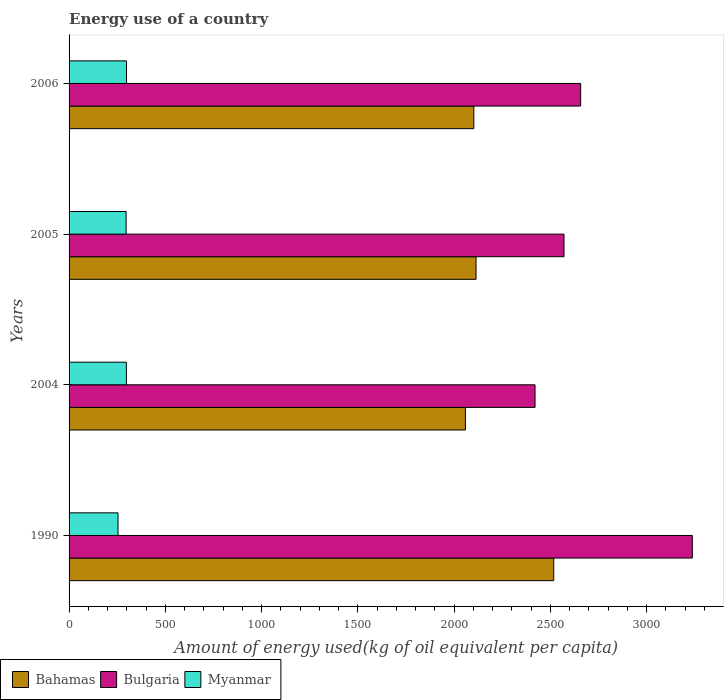How many different coloured bars are there?
Provide a succinct answer. 3. How many groups of bars are there?
Provide a short and direct response. 4. Are the number of bars on each tick of the Y-axis equal?
Your response must be concise. Yes. How many bars are there on the 4th tick from the top?
Offer a very short reply. 3. What is the label of the 4th group of bars from the top?
Offer a very short reply. 1990. What is the amount of energy used in in Myanmar in 2004?
Provide a succinct answer. 297.64. Across all years, what is the maximum amount of energy used in in Myanmar?
Your response must be concise. 298.12. Across all years, what is the minimum amount of energy used in in Bulgaria?
Offer a very short reply. 2420.35. In which year was the amount of energy used in in Bulgaria maximum?
Offer a very short reply. 1990. What is the total amount of energy used in in Bahamas in the graph?
Give a very brief answer. 8792.49. What is the difference between the amount of energy used in in Bulgaria in 1990 and that in 2006?
Provide a short and direct response. 580.03. What is the difference between the amount of energy used in in Myanmar in 2006 and the amount of energy used in in Bahamas in 2005?
Offer a terse response. -1815.82. What is the average amount of energy used in in Bulgaria per year?
Give a very brief answer. 2721.47. In the year 2004, what is the difference between the amount of energy used in in Myanmar and amount of energy used in in Bahamas?
Keep it short and to the point. -1761.02. What is the ratio of the amount of energy used in in Bahamas in 2005 to that in 2006?
Your answer should be compact. 1.01. Is the difference between the amount of energy used in in Myanmar in 2004 and 2005 greater than the difference between the amount of energy used in in Bahamas in 2004 and 2005?
Your answer should be very brief. Yes. What is the difference between the highest and the second highest amount of energy used in in Myanmar?
Your answer should be compact. 0.47. What is the difference between the highest and the lowest amount of energy used in in Myanmar?
Give a very brief answer. 43.89. What does the 3rd bar from the bottom in 2005 represents?
Your answer should be compact. Myanmar. Are all the bars in the graph horizontal?
Your answer should be very brief. Yes. How many years are there in the graph?
Offer a very short reply. 4. What is the difference between two consecutive major ticks on the X-axis?
Keep it short and to the point. 500. Does the graph contain grids?
Offer a very short reply. No. Where does the legend appear in the graph?
Give a very brief answer. Bottom left. What is the title of the graph?
Your response must be concise. Energy use of a country. What is the label or title of the X-axis?
Provide a short and direct response. Amount of energy used(kg of oil equivalent per capita). What is the label or title of the Y-axis?
Offer a terse response. Years. What is the Amount of energy used(kg of oil equivalent per capita) in Bahamas in 1990?
Provide a short and direct response. 2517.45. What is the Amount of energy used(kg of oil equivalent per capita) of Bulgaria in 1990?
Provide a short and direct response. 3237.35. What is the Amount of energy used(kg of oil equivalent per capita) of Myanmar in 1990?
Make the answer very short. 254.23. What is the Amount of energy used(kg of oil equivalent per capita) of Bahamas in 2004?
Your response must be concise. 2058.67. What is the Amount of energy used(kg of oil equivalent per capita) of Bulgaria in 2004?
Your answer should be very brief. 2420.35. What is the Amount of energy used(kg of oil equivalent per capita) of Myanmar in 2004?
Keep it short and to the point. 297.64. What is the Amount of energy used(kg of oil equivalent per capita) of Bahamas in 2005?
Your answer should be very brief. 2113.94. What is the Amount of energy used(kg of oil equivalent per capita) of Bulgaria in 2005?
Your answer should be very brief. 2570.86. What is the Amount of energy used(kg of oil equivalent per capita) of Myanmar in 2005?
Your answer should be very brief. 296.38. What is the Amount of energy used(kg of oil equivalent per capita) in Bahamas in 2006?
Make the answer very short. 2102.44. What is the Amount of energy used(kg of oil equivalent per capita) in Bulgaria in 2006?
Provide a succinct answer. 2657.33. What is the Amount of energy used(kg of oil equivalent per capita) of Myanmar in 2006?
Your response must be concise. 298.12. Across all years, what is the maximum Amount of energy used(kg of oil equivalent per capita) of Bahamas?
Your answer should be very brief. 2517.45. Across all years, what is the maximum Amount of energy used(kg of oil equivalent per capita) of Bulgaria?
Provide a succinct answer. 3237.35. Across all years, what is the maximum Amount of energy used(kg of oil equivalent per capita) in Myanmar?
Offer a very short reply. 298.12. Across all years, what is the minimum Amount of energy used(kg of oil equivalent per capita) in Bahamas?
Keep it short and to the point. 2058.67. Across all years, what is the minimum Amount of energy used(kg of oil equivalent per capita) in Bulgaria?
Offer a very short reply. 2420.35. Across all years, what is the minimum Amount of energy used(kg of oil equivalent per capita) in Myanmar?
Offer a terse response. 254.23. What is the total Amount of energy used(kg of oil equivalent per capita) in Bahamas in the graph?
Keep it short and to the point. 8792.49. What is the total Amount of energy used(kg of oil equivalent per capita) of Bulgaria in the graph?
Offer a very short reply. 1.09e+04. What is the total Amount of energy used(kg of oil equivalent per capita) in Myanmar in the graph?
Keep it short and to the point. 1146.36. What is the difference between the Amount of energy used(kg of oil equivalent per capita) in Bahamas in 1990 and that in 2004?
Provide a succinct answer. 458.78. What is the difference between the Amount of energy used(kg of oil equivalent per capita) of Bulgaria in 1990 and that in 2004?
Provide a succinct answer. 817. What is the difference between the Amount of energy used(kg of oil equivalent per capita) in Myanmar in 1990 and that in 2004?
Make the answer very short. -43.42. What is the difference between the Amount of energy used(kg of oil equivalent per capita) in Bahamas in 1990 and that in 2005?
Make the answer very short. 403.51. What is the difference between the Amount of energy used(kg of oil equivalent per capita) in Bulgaria in 1990 and that in 2005?
Your answer should be compact. 666.49. What is the difference between the Amount of energy used(kg of oil equivalent per capita) of Myanmar in 1990 and that in 2005?
Ensure brevity in your answer.  -42.15. What is the difference between the Amount of energy used(kg of oil equivalent per capita) of Bahamas in 1990 and that in 2006?
Your answer should be compact. 415.01. What is the difference between the Amount of energy used(kg of oil equivalent per capita) of Bulgaria in 1990 and that in 2006?
Give a very brief answer. 580.03. What is the difference between the Amount of energy used(kg of oil equivalent per capita) of Myanmar in 1990 and that in 2006?
Offer a very short reply. -43.89. What is the difference between the Amount of energy used(kg of oil equivalent per capita) of Bahamas in 2004 and that in 2005?
Your answer should be very brief. -55.27. What is the difference between the Amount of energy used(kg of oil equivalent per capita) in Bulgaria in 2004 and that in 2005?
Provide a succinct answer. -150.51. What is the difference between the Amount of energy used(kg of oil equivalent per capita) in Myanmar in 2004 and that in 2005?
Give a very brief answer. 1.26. What is the difference between the Amount of energy used(kg of oil equivalent per capita) of Bahamas in 2004 and that in 2006?
Your answer should be compact. -43.77. What is the difference between the Amount of energy used(kg of oil equivalent per capita) of Bulgaria in 2004 and that in 2006?
Keep it short and to the point. -236.97. What is the difference between the Amount of energy used(kg of oil equivalent per capita) in Myanmar in 2004 and that in 2006?
Provide a short and direct response. -0.47. What is the difference between the Amount of energy used(kg of oil equivalent per capita) of Bahamas in 2005 and that in 2006?
Give a very brief answer. 11.5. What is the difference between the Amount of energy used(kg of oil equivalent per capita) in Bulgaria in 2005 and that in 2006?
Make the answer very short. -86.47. What is the difference between the Amount of energy used(kg of oil equivalent per capita) in Myanmar in 2005 and that in 2006?
Make the answer very short. -1.74. What is the difference between the Amount of energy used(kg of oil equivalent per capita) of Bahamas in 1990 and the Amount of energy used(kg of oil equivalent per capita) of Bulgaria in 2004?
Offer a very short reply. 97.09. What is the difference between the Amount of energy used(kg of oil equivalent per capita) in Bahamas in 1990 and the Amount of energy used(kg of oil equivalent per capita) in Myanmar in 2004?
Give a very brief answer. 2219.8. What is the difference between the Amount of energy used(kg of oil equivalent per capita) in Bulgaria in 1990 and the Amount of energy used(kg of oil equivalent per capita) in Myanmar in 2004?
Provide a short and direct response. 2939.71. What is the difference between the Amount of energy used(kg of oil equivalent per capita) in Bahamas in 1990 and the Amount of energy used(kg of oil equivalent per capita) in Bulgaria in 2005?
Your answer should be compact. -53.41. What is the difference between the Amount of energy used(kg of oil equivalent per capita) in Bahamas in 1990 and the Amount of energy used(kg of oil equivalent per capita) in Myanmar in 2005?
Ensure brevity in your answer.  2221.07. What is the difference between the Amount of energy used(kg of oil equivalent per capita) in Bulgaria in 1990 and the Amount of energy used(kg of oil equivalent per capita) in Myanmar in 2005?
Offer a very short reply. 2940.97. What is the difference between the Amount of energy used(kg of oil equivalent per capita) of Bahamas in 1990 and the Amount of energy used(kg of oil equivalent per capita) of Bulgaria in 2006?
Offer a very short reply. -139.88. What is the difference between the Amount of energy used(kg of oil equivalent per capita) of Bahamas in 1990 and the Amount of energy used(kg of oil equivalent per capita) of Myanmar in 2006?
Keep it short and to the point. 2219.33. What is the difference between the Amount of energy used(kg of oil equivalent per capita) of Bulgaria in 1990 and the Amount of energy used(kg of oil equivalent per capita) of Myanmar in 2006?
Keep it short and to the point. 2939.24. What is the difference between the Amount of energy used(kg of oil equivalent per capita) of Bahamas in 2004 and the Amount of energy used(kg of oil equivalent per capita) of Bulgaria in 2005?
Your response must be concise. -512.19. What is the difference between the Amount of energy used(kg of oil equivalent per capita) of Bahamas in 2004 and the Amount of energy used(kg of oil equivalent per capita) of Myanmar in 2005?
Your answer should be very brief. 1762.29. What is the difference between the Amount of energy used(kg of oil equivalent per capita) of Bulgaria in 2004 and the Amount of energy used(kg of oil equivalent per capita) of Myanmar in 2005?
Ensure brevity in your answer.  2123.97. What is the difference between the Amount of energy used(kg of oil equivalent per capita) of Bahamas in 2004 and the Amount of energy used(kg of oil equivalent per capita) of Bulgaria in 2006?
Provide a short and direct response. -598.66. What is the difference between the Amount of energy used(kg of oil equivalent per capita) of Bahamas in 2004 and the Amount of energy used(kg of oil equivalent per capita) of Myanmar in 2006?
Provide a short and direct response. 1760.55. What is the difference between the Amount of energy used(kg of oil equivalent per capita) of Bulgaria in 2004 and the Amount of energy used(kg of oil equivalent per capita) of Myanmar in 2006?
Provide a succinct answer. 2122.24. What is the difference between the Amount of energy used(kg of oil equivalent per capita) in Bahamas in 2005 and the Amount of energy used(kg of oil equivalent per capita) in Bulgaria in 2006?
Give a very brief answer. -543.38. What is the difference between the Amount of energy used(kg of oil equivalent per capita) in Bahamas in 2005 and the Amount of energy used(kg of oil equivalent per capita) in Myanmar in 2006?
Provide a short and direct response. 1815.82. What is the difference between the Amount of energy used(kg of oil equivalent per capita) of Bulgaria in 2005 and the Amount of energy used(kg of oil equivalent per capita) of Myanmar in 2006?
Provide a short and direct response. 2272.74. What is the average Amount of energy used(kg of oil equivalent per capita) of Bahamas per year?
Your response must be concise. 2198.12. What is the average Amount of energy used(kg of oil equivalent per capita) of Bulgaria per year?
Offer a terse response. 2721.47. What is the average Amount of energy used(kg of oil equivalent per capita) of Myanmar per year?
Offer a terse response. 286.59. In the year 1990, what is the difference between the Amount of energy used(kg of oil equivalent per capita) in Bahamas and Amount of energy used(kg of oil equivalent per capita) in Bulgaria?
Your response must be concise. -719.91. In the year 1990, what is the difference between the Amount of energy used(kg of oil equivalent per capita) of Bahamas and Amount of energy used(kg of oil equivalent per capita) of Myanmar?
Make the answer very short. 2263.22. In the year 1990, what is the difference between the Amount of energy used(kg of oil equivalent per capita) in Bulgaria and Amount of energy used(kg of oil equivalent per capita) in Myanmar?
Give a very brief answer. 2983.13. In the year 2004, what is the difference between the Amount of energy used(kg of oil equivalent per capita) of Bahamas and Amount of energy used(kg of oil equivalent per capita) of Bulgaria?
Keep it short and to the point. -361.69. In the year 2004, what is the difference between the Amount of energy used(kg of oil equivalent per capita) in Bahamas and Amount of energy used(kg of oil equivalent per capita) in Myanmar?
Your answer should be compact. 1761.02. In the year 2004, what is the difference between the Amount of energy used(kg of oil equivalent per capita) of Bulgaria and Amount of energy used(kg of oil equivalent per capita) of Myanmar?
Your answer should be compact. 2122.71. In the year 2005, what is the difference between the Amount of energy used(kg of oil equivalent per capita) of Bahamas and Amount of energy used(kg of oil equivalent per capita) of Bulgaria?
Provide a succinct answer. -456.92. In the year 2005, what is the difference between the Amount of energy used(kg of oil equivalent per capita) of Bahamas and Amount of energy used(kg of oil equivalent per capita) of Myanmar?
Your response must be concise. 1817.56. In the year 2005, what is the difference between the Amount of energy used(kg of oil equivalent per capita) in Bulgaria and Amount of energy used(kg of oil equivalent per capita) in Myanmar?
Ensure brevity in your answer.  2274.48. In the year 2006, what is the difference between the Amount of energy used(kg of oil equivalent per capita) in Bahamas and Amount of energy used(kg of oil equivalent per capita) in Bulgaria?
Provide a succinct answer. -554.89. In the year 2006, what is the difference between the Amount of energy used(kg of oil equivalent per capita) in Bahamas and Amount of energy used(kg of oil equivalent per capita) in Myanmar?
Provide a short and direct response. 1804.32. In the year 2006, what is the difference between the Amount of energy used(kg of oil equivalent per capita) of Bulgaria and Amount of energy used(kg of oil equivalent per capita) of Myanmar?
Ensure brevity in your answer.  2359.21. What is the ratio of the Amount of energy used(kg of oil equivalent per capita) in Bahamas in 1990 to that in 2004?
Your response must be concise. 1.22. What is the ratio of the Amount of energy used(kg of oil equivalent per capita) of Bulgaria in 1990 to that in 2004?
Keep it short and to the point. 1.34. What is the ratio of the Amount of energy used(kg of oil equivalent per capita) in Myanmar in 1990 to that in 2004?
Provide a short and direct response. 0.85. What is the ratio of the Amount of energy used(kg of oil equivalent per capita) in Bahamas in 1990 to that in 2005?
Make the answer very short. 1.19. What is the ratio of the Amount of energy used(kg of oil equivalent per capita) in Bulgaria in 1990 to that in 2005?
Keep it short and to the point. 1.26. What is the ratio of the Amount of energy used(kg of oil equivalent per capita) in Myanmar in 1990 to that in 2005?
Keep it short and to the point. 0.86. What is the ratio of the Amount of energy used(kg of oil equivalent per capita) in Bahamas in 1990 to that in 2006?
Provide a succinct answer. 1.2. What is the ratio of the Amount of energy used(kg of oil equivalent per capita) in Bulgaria in 1990 to that in 2006?
Ensure brevity in your answer.  1.22. What is the ratio of the Amount of energy used(kg of oil equivalent per capita) of Myanmar in 1990 to that in 2006?
Your response must be concise. 0.85. What is the ratio of the Amount of energy used(kg of oil equivalent per capita) of Bahamas in 2004 to that in 2005?
Your response must be concise. 0.97. What is the ratio of the Amount of energy used(kg of oil equivalent per capita) of Bulgaria in 2004 to that in 2005?
Offer a terse response. 0.94. What is the ratio of the Amount of energy used(kg of oil equivalent per capita) of Bahamas in 2004 to that in 2006?
Your response must be concise. 0.98. What is the ratio of the Amount of energy used(kg of oil equivalent per capita) in Bulgaria in 2004 to that in 2006?
Provide a succinct answer. 0.91. What is the ratio of the Amount of energy used(kg of oil equivalent per capita) in Myanmar in 2004 to that in 2006?
Keep it short and to the point. 1. What is the ratio of the Amount of energy used(kg of oil equivalent per capita) of Bahamas in 2005 to that in 2006?
Your response must be concise. 1.01. What is the ratio of the Amount of energy used(kg of oil equivalent per capita) of Bulgaria in 2005 to that in 2006?
Your response must be concise. 0.97. What is the difference between the highest and the second highest Amount of energy used(kg of oil equivalent per capita) of Bahamas?
Provide a succinct answer. 403.51. What is the difference between the highest and the second highest Amount of energy used(kg of oil equivalent per capita) in Bulgaria?
Offer a terse response. 580.03. What is the difference between the highest and the second highest Amount of energy used(kg of oil equivalent per capita) of Myanmar?
Provide a short and direct response. 0.47. What is the difference between the highest and the lowest Amount of energy used(kg of oil equivalent per capita) in Bahamas?
Offer a very short reply. 458.78. What is the difference between the highest and the lowest Amount of energy used(kg of oil equivalent per capita) in Bulgaria?
Your response must be concise. 817. What is the difference between the highest and the lowest Amount of energy used(kg of oil equivalent per capita) of Myanmar?
Provide a succinct answer. 43.89. 